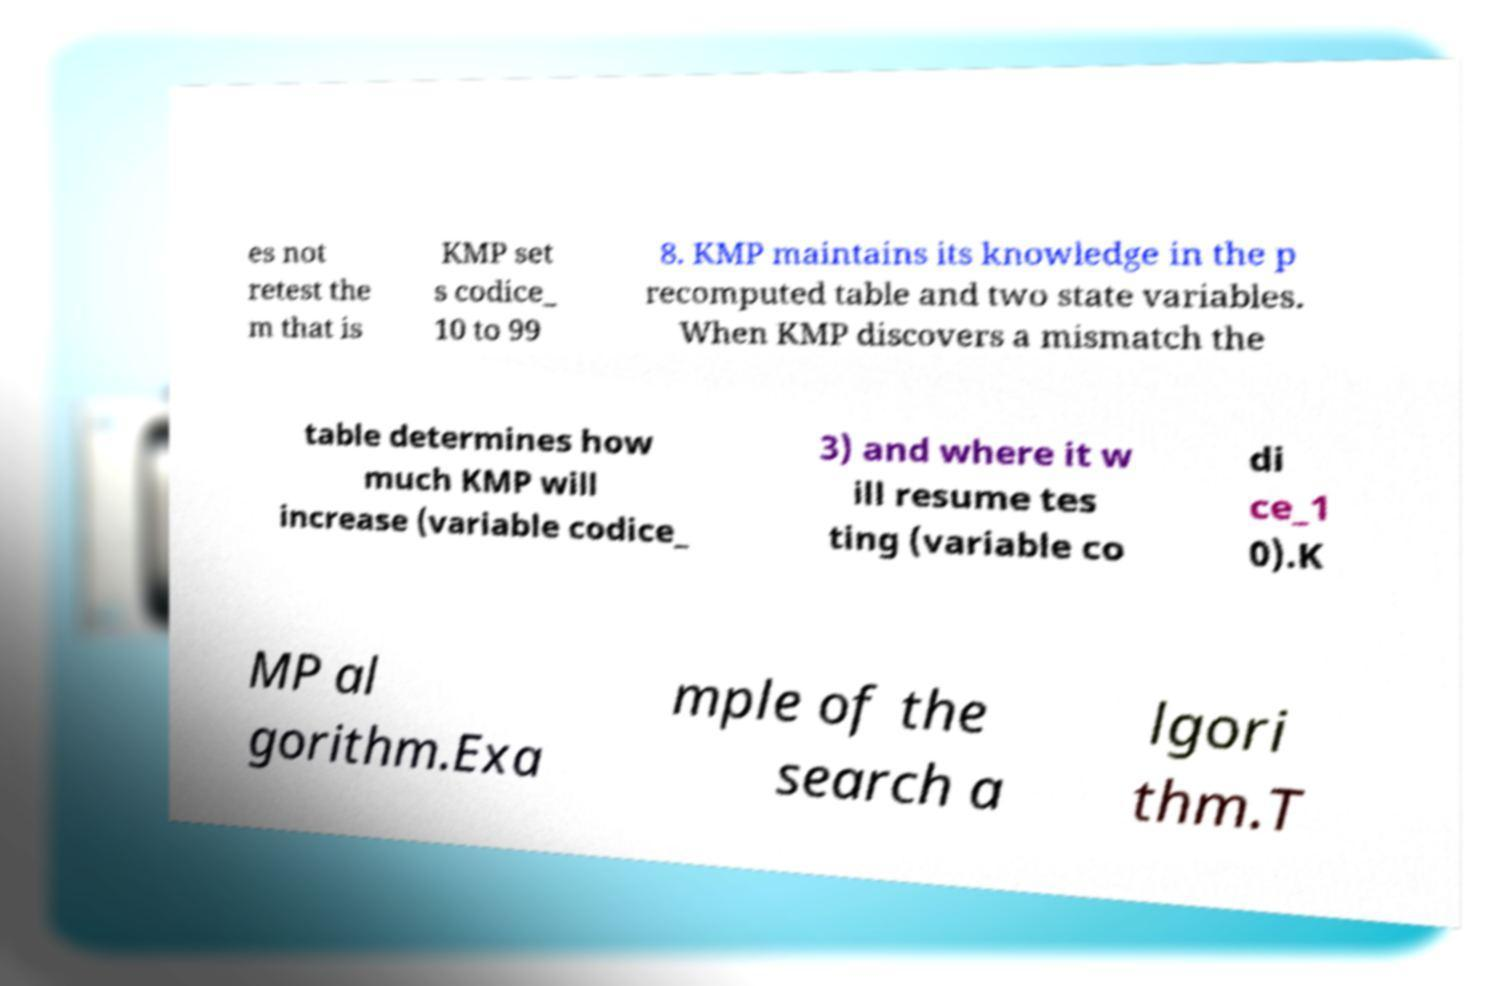There's text embedded in this image that I need extracted. Can you transcribe it verbatim? es not retest the m that is KMP set s codice_ 10 to 99 8. KMP maintains its knowledge in the p recomputed table and two state variables. When KMP discovers a mismatch the table determines how much KMP will increase (variable codice_ 3) and where it w ill resume tes ting (variable co di ce_1 0).K MP al gorithm.Exa mple of the search a lgori thm.T 